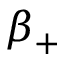Convert formula to latex. <formula><loc_0><loc_0><loc_500><loc_500>\beta _ { + }</formula> 